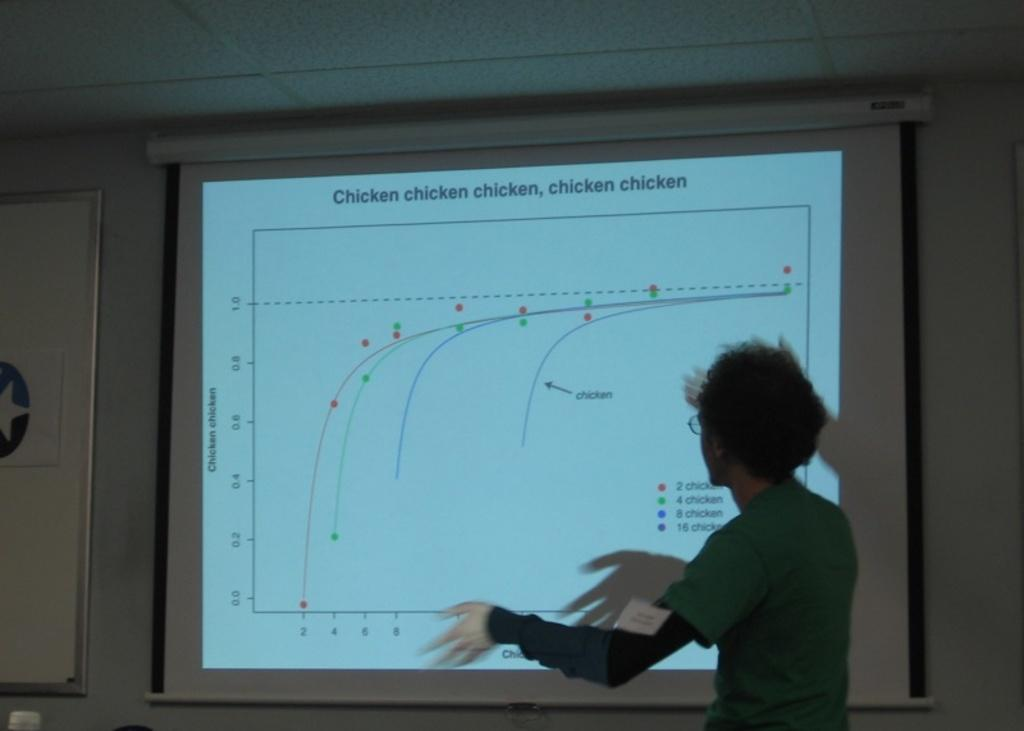<image>
Provide a brief description of the given image. Person in front of a board which says chicken on the top. 